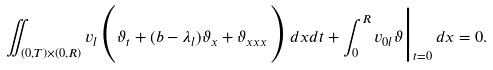Convert formula to latex. <formula><loc_0><loc_0><loc_500><loc_500>\iint _ { ( 0 , T ) \times ( 0 , R ) } v _ { l } \Big ( \vartheta _ { t } + ( b - \lambda _ { l } ) \vartheta _ { x } + \vartheta _ { x x x } \Big ) \, d x d t + \int _ { 0 } ^ { R } v _ { 0 l } \vartheta \Big | _ { t = 0 } \, d x = 0 .</formula> 